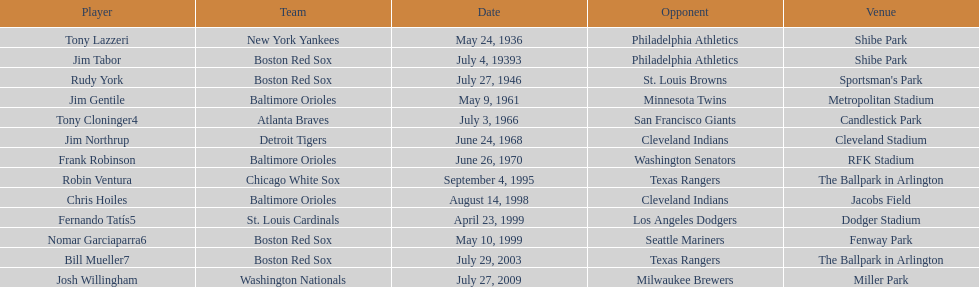Who were all the team members? Tony Lazzeri, Jim Tabor, Rudy York, Jim Gentile, Tony Cloninger4, Jim Northrup, Frank Robinson, Robin Ventura, Chris Hoiles, Fernando Tatís5, Nomar Garciaparra6, Bill Mueller7, Josh Willingham. In what year was there a member for the yankees? May 24, 1936. What was the name of that 1936 yankees team member? Tony Lazzeri. 